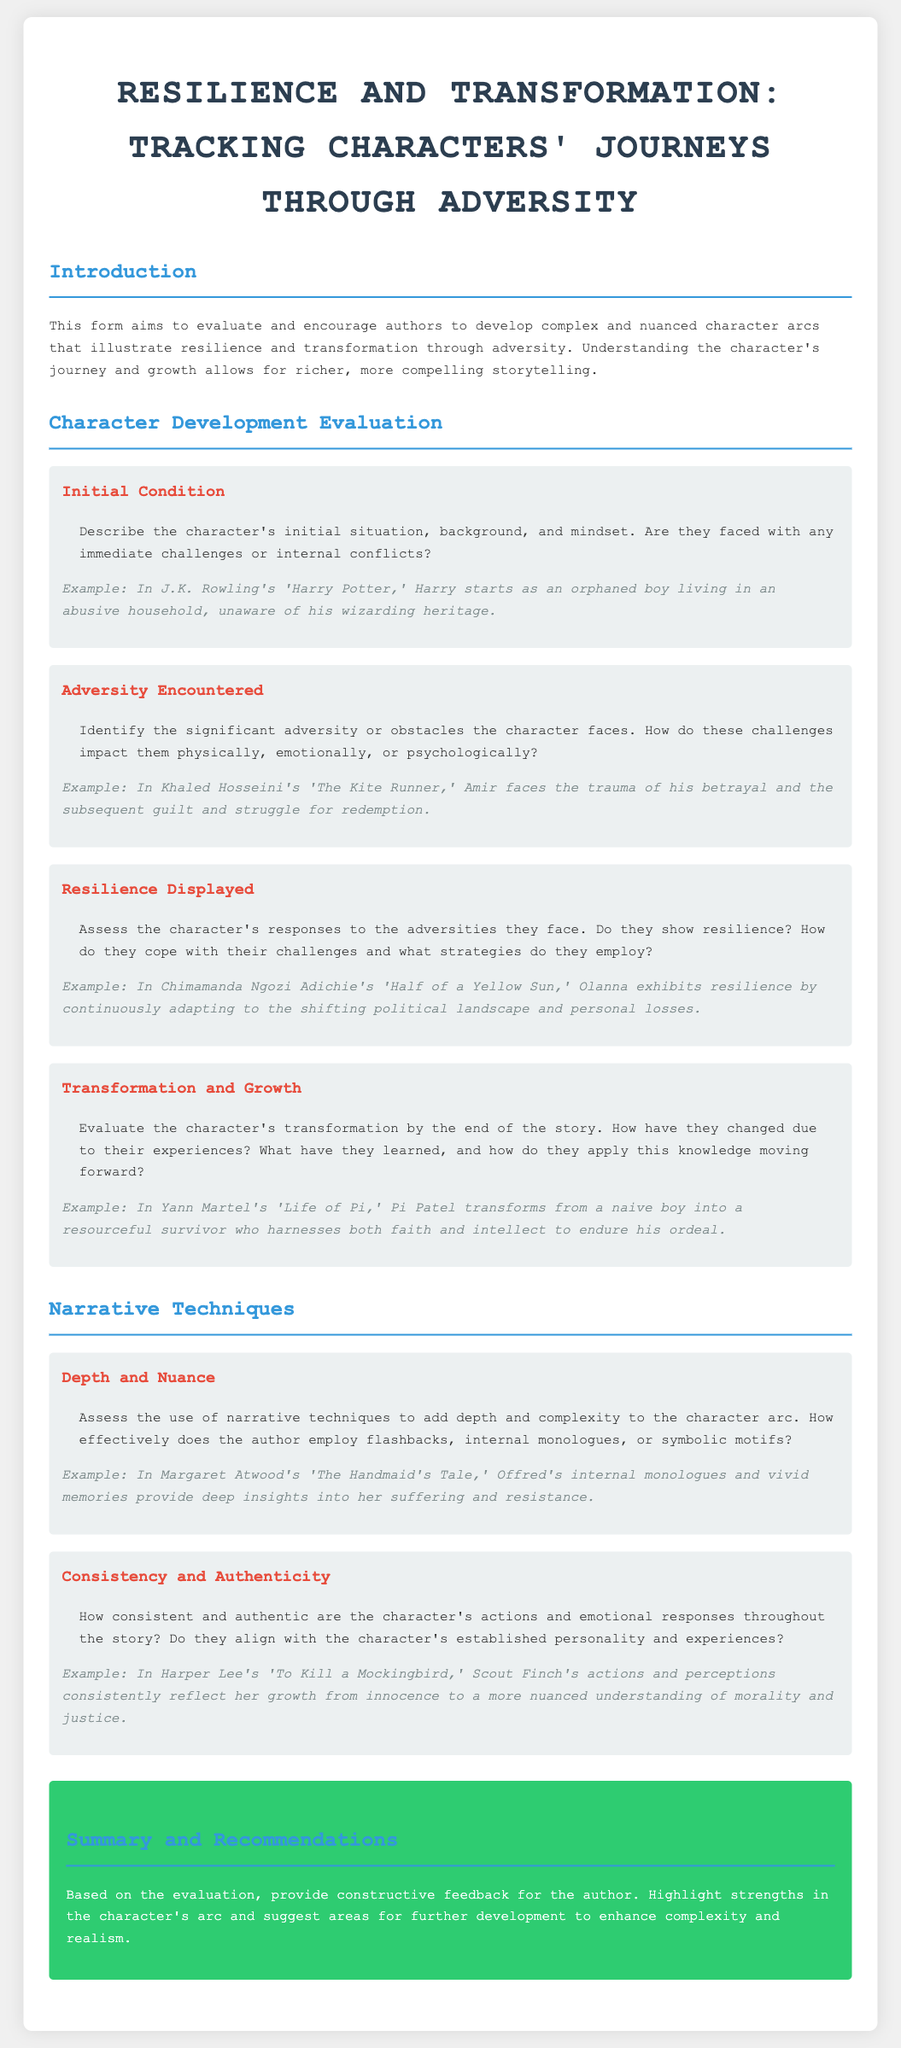What is the title of the document? The title of the document is indicated in the head section as well as the main heading.
Answer: Resilience and Transformation: Tracking Characters' Journeys Through Adversity What is the primary purpose of this form? The purpose is described in the introduction, focusing on character arcs and storytelling.
Answer: To evaluate and encourage authors to develop complex and nuanced character arcs What is the first category evaluated under Character Development? The categories are listed under Character Development Evaluation, the first being Initial Condition.
Answer: Initial Condition Which author and title is used as an example for the Resilience Displayed category? The example can be found in the Resilience Displayed section and is specifically noted.
Answer: Half of a Yellow Sun What technique does the document mention to add depth and complexity? This is specified in the Depth and Nuance section, focusing on narrative techniques.
Answer: Flashbacks, internal monologues, or symbolic motifs What character does the document reference in the Initial Condition example? The example is provided in the Initial Condition category, highlighting a well-known character.
Answer: Harry Potter How is transformation assessed in the character arc? This is described in the Transformation and Growth section, focusing on specific questions.
Answer: Evaluate the character's transformation by the end of the story What color is used for the summary section in the document? The summary section is highlighted with a specific background color noted in the styles section.
Answer: Green 